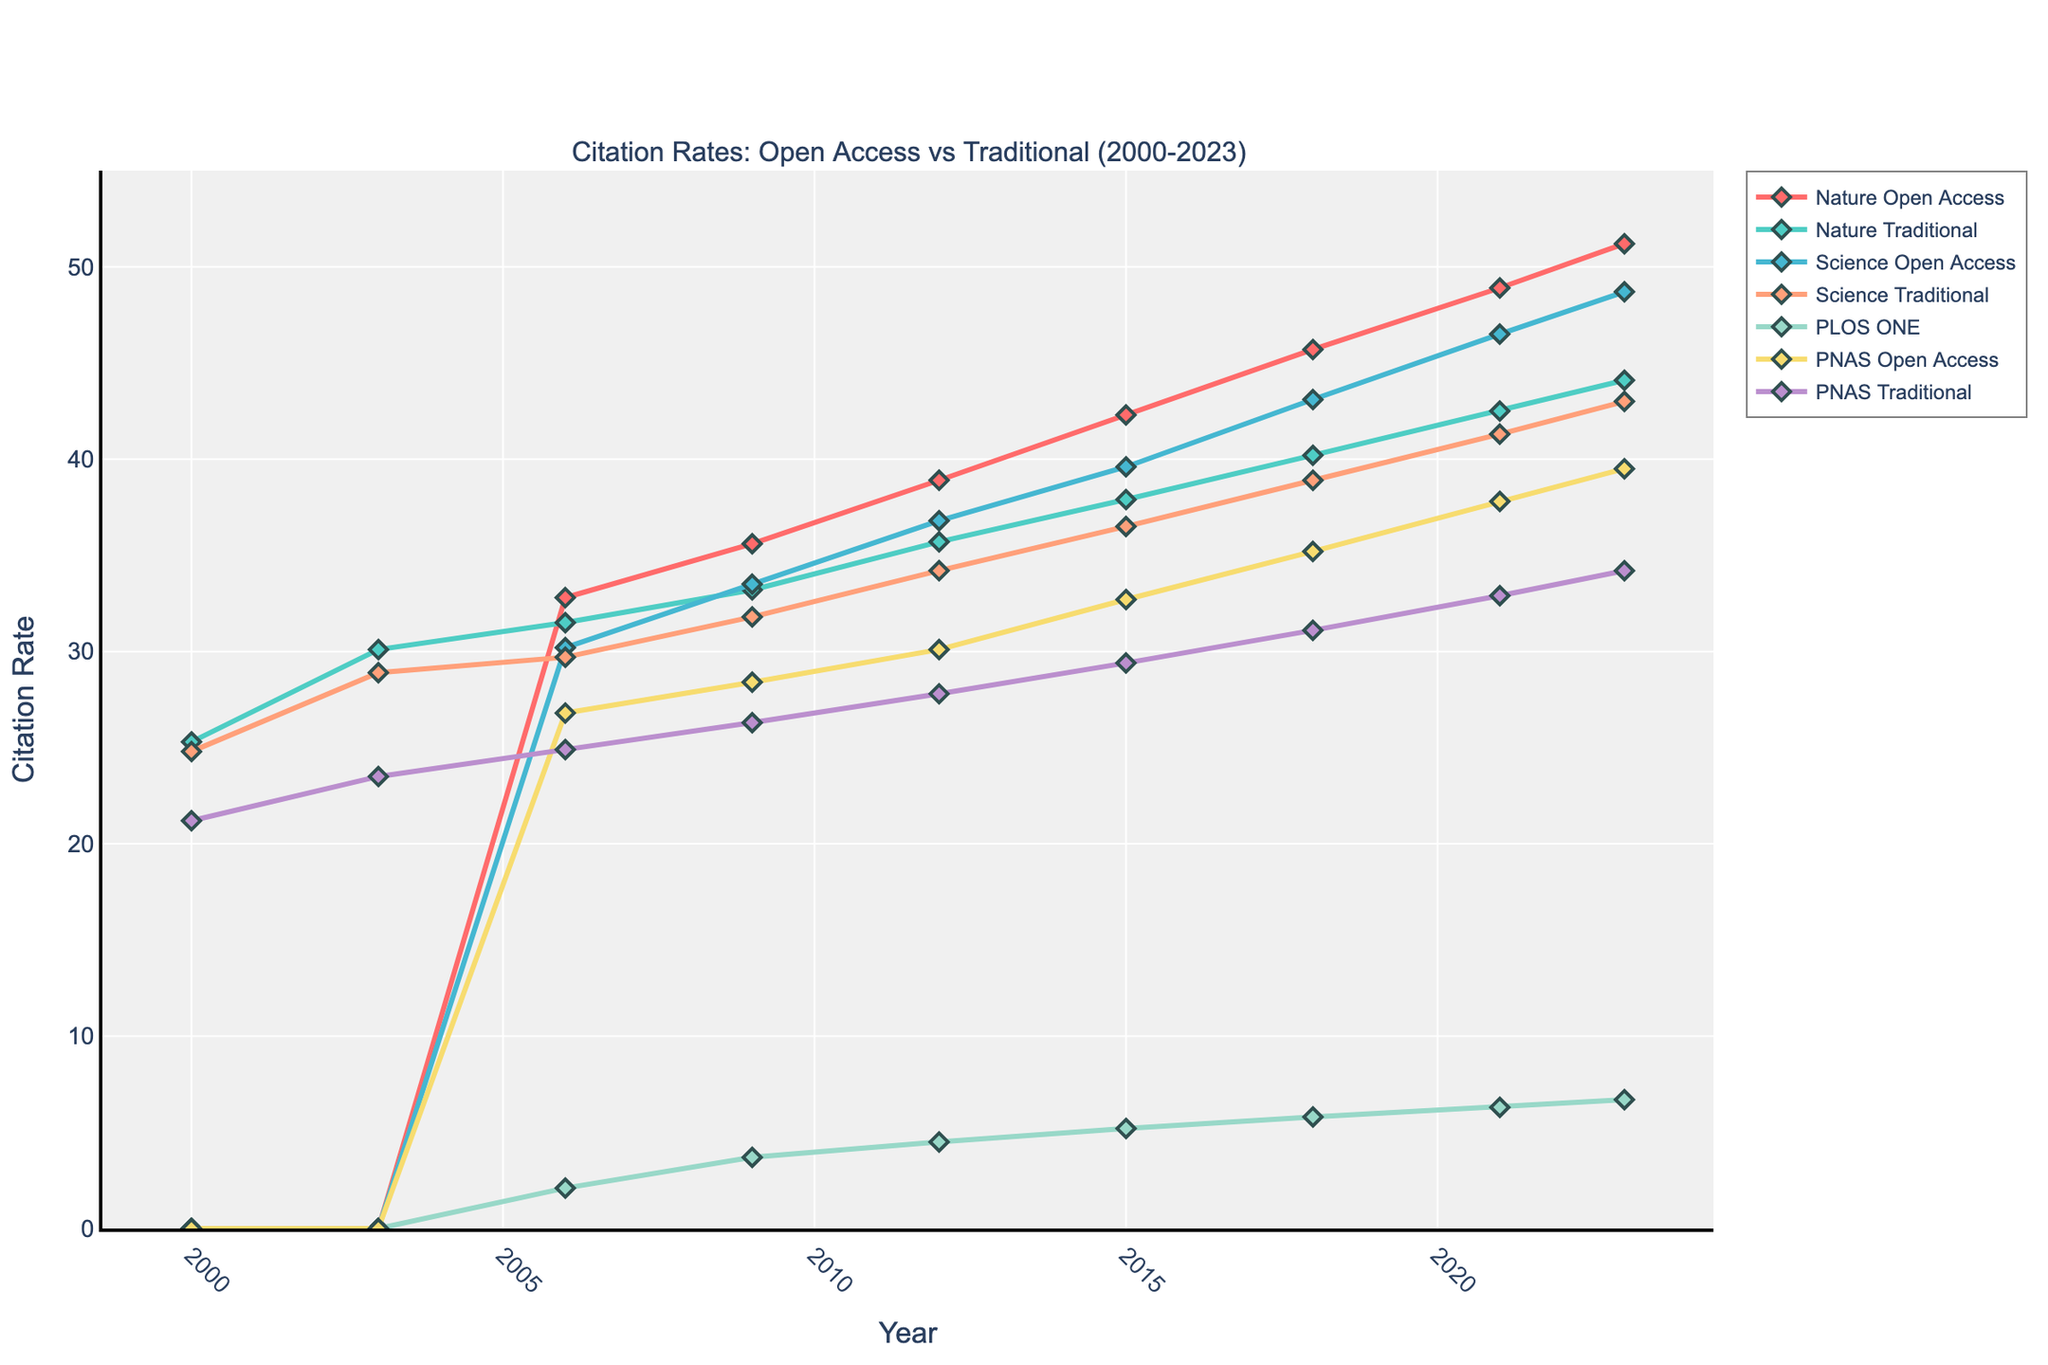What is the citation rate trend for Nature Open Access articles from 2000 to 2023? The citation rate for Nature Open Access articles starts at 0 in 2000, then increases steadily from 32.8 in 2006 to 51.2 in 2023.
Answer: Steady increase In 2009, which journal's traditional articles had the highest citation rate? Comparing the citation rates of traditional articles in 2009: Nature (33.2), Science (31.8), and PNAS (26.3). Nature Traditional has the highest.
Answer: Nature Traditional What is the difference in citation rates between PLOS ONE and Science Open Access in 2023? In 2023, PLOS ONE has a citation rate of 6.7, and Science Open Access has 48.7. The difference is 48.7 - 6.7 = 42.0.
Answer: 42.0 Which journal's Open Access articles had the highest growth in citation rates from 2006 to 2023? Calculate the growth for each journal's Open Access articles: Nature (51.2 - 32.8 = 18.4), Science (48.7 - 30.2 = 18.5), PLOS ONE (6.7 - 2.1 = 4.6), PNAS (39.5 - 26.8 = 12.7). Science has the highest growth.
Answer: Science What is the average citation rate of PNAS articles (both Open Access and Traditional) in 2018? PNAS Open Access citation rate in 2018 is 35.2, and PNAS Traditional is 31.1. The average is (35.2 + 31.1) / 2 = 33.15.
Answer: 33.15 Between 2015 and 2021, did the citation rate of Nature Traditional articles increase or decrease? The citation rate for Nature Traditional articles in 2015 is 37.9, and in 2021 is 42.5. Comparing these values shows an increase.
Answer: Increase Which journal had the smallest difference in citation rates between Open Access and Traditional articles in 2023? Calculate the differences in citation rates in 2023 for each journal: Nature (51.2 - 44.1 = 7.1), Science (48.7 - 43.0 = 5.7), PNAS (39.5 - 34.2 = 5.3). The smallest difference is for PNAS.
Answer: PNAS What is the range of citation rates for all journals combined in 2012? The citation rates in 2012 are: Nature Open Access (38.9), Nature Traditional (35.7), Science Open Access (36.8), Science Traditional (34.2), PLOS ONE (4.5), PNAS Open Access (30.1), PNAS Traditional (27.8). The range is 38.9 - 4.5 = 34.4.
Answer: 34.4 